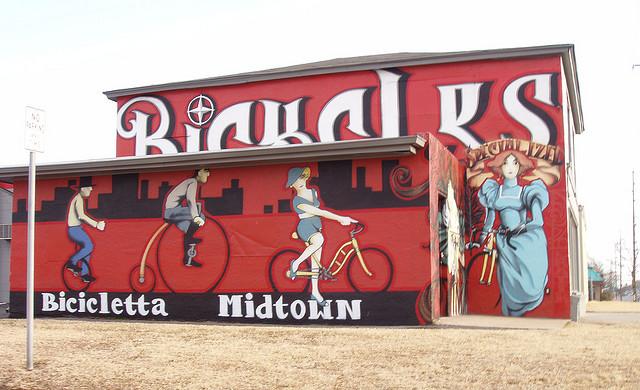Is this a garage?
Give a very brief answer. Yes. Is this a circus?
Answer briefly. Yes. What kind of show is this?
Short answer required. Bicycle. 